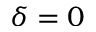<formula> <loc_0><loc_0><loc_500><loc_500>\delta = 0</formula> 